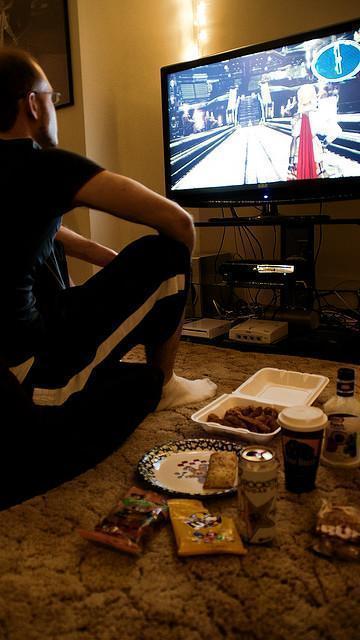What type dressing does this man favor?
Indicate the correct response and explain using: 'Answer: answer
Rationale: rationale.'
Options: Ranch, green goddess, thousand island, french. Answer: ranch.
Rationale: The dressing is ranch. 